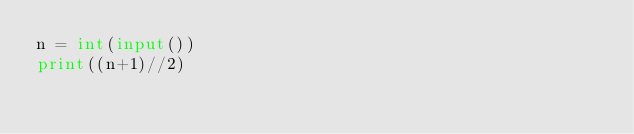Convert code to text. <code><loc_0><loc_0><loc_500><loc_500><_Python_>n = int(input())
print((n+1)//2)</code> 